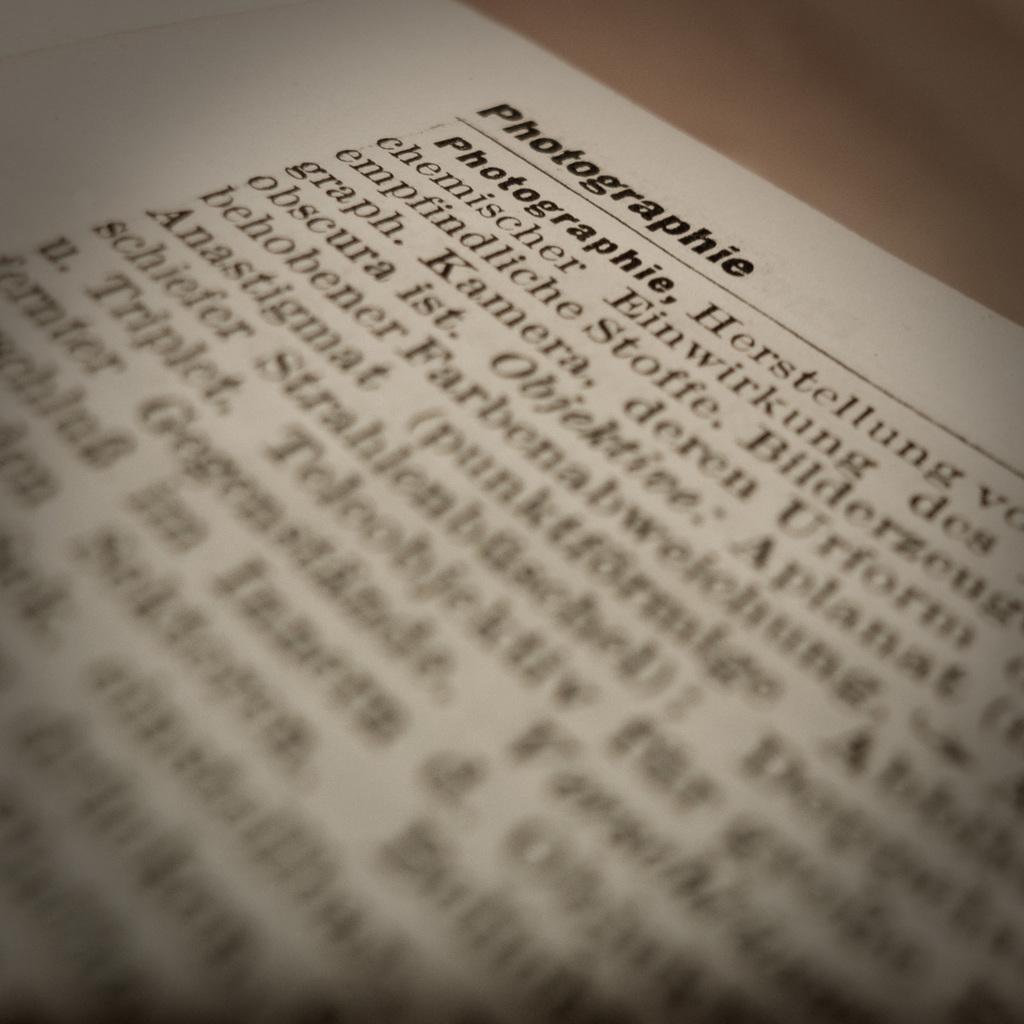Describe this image in one or two sentences. In this image I can see the text on the white color paper. The paper is on the brown color table. 